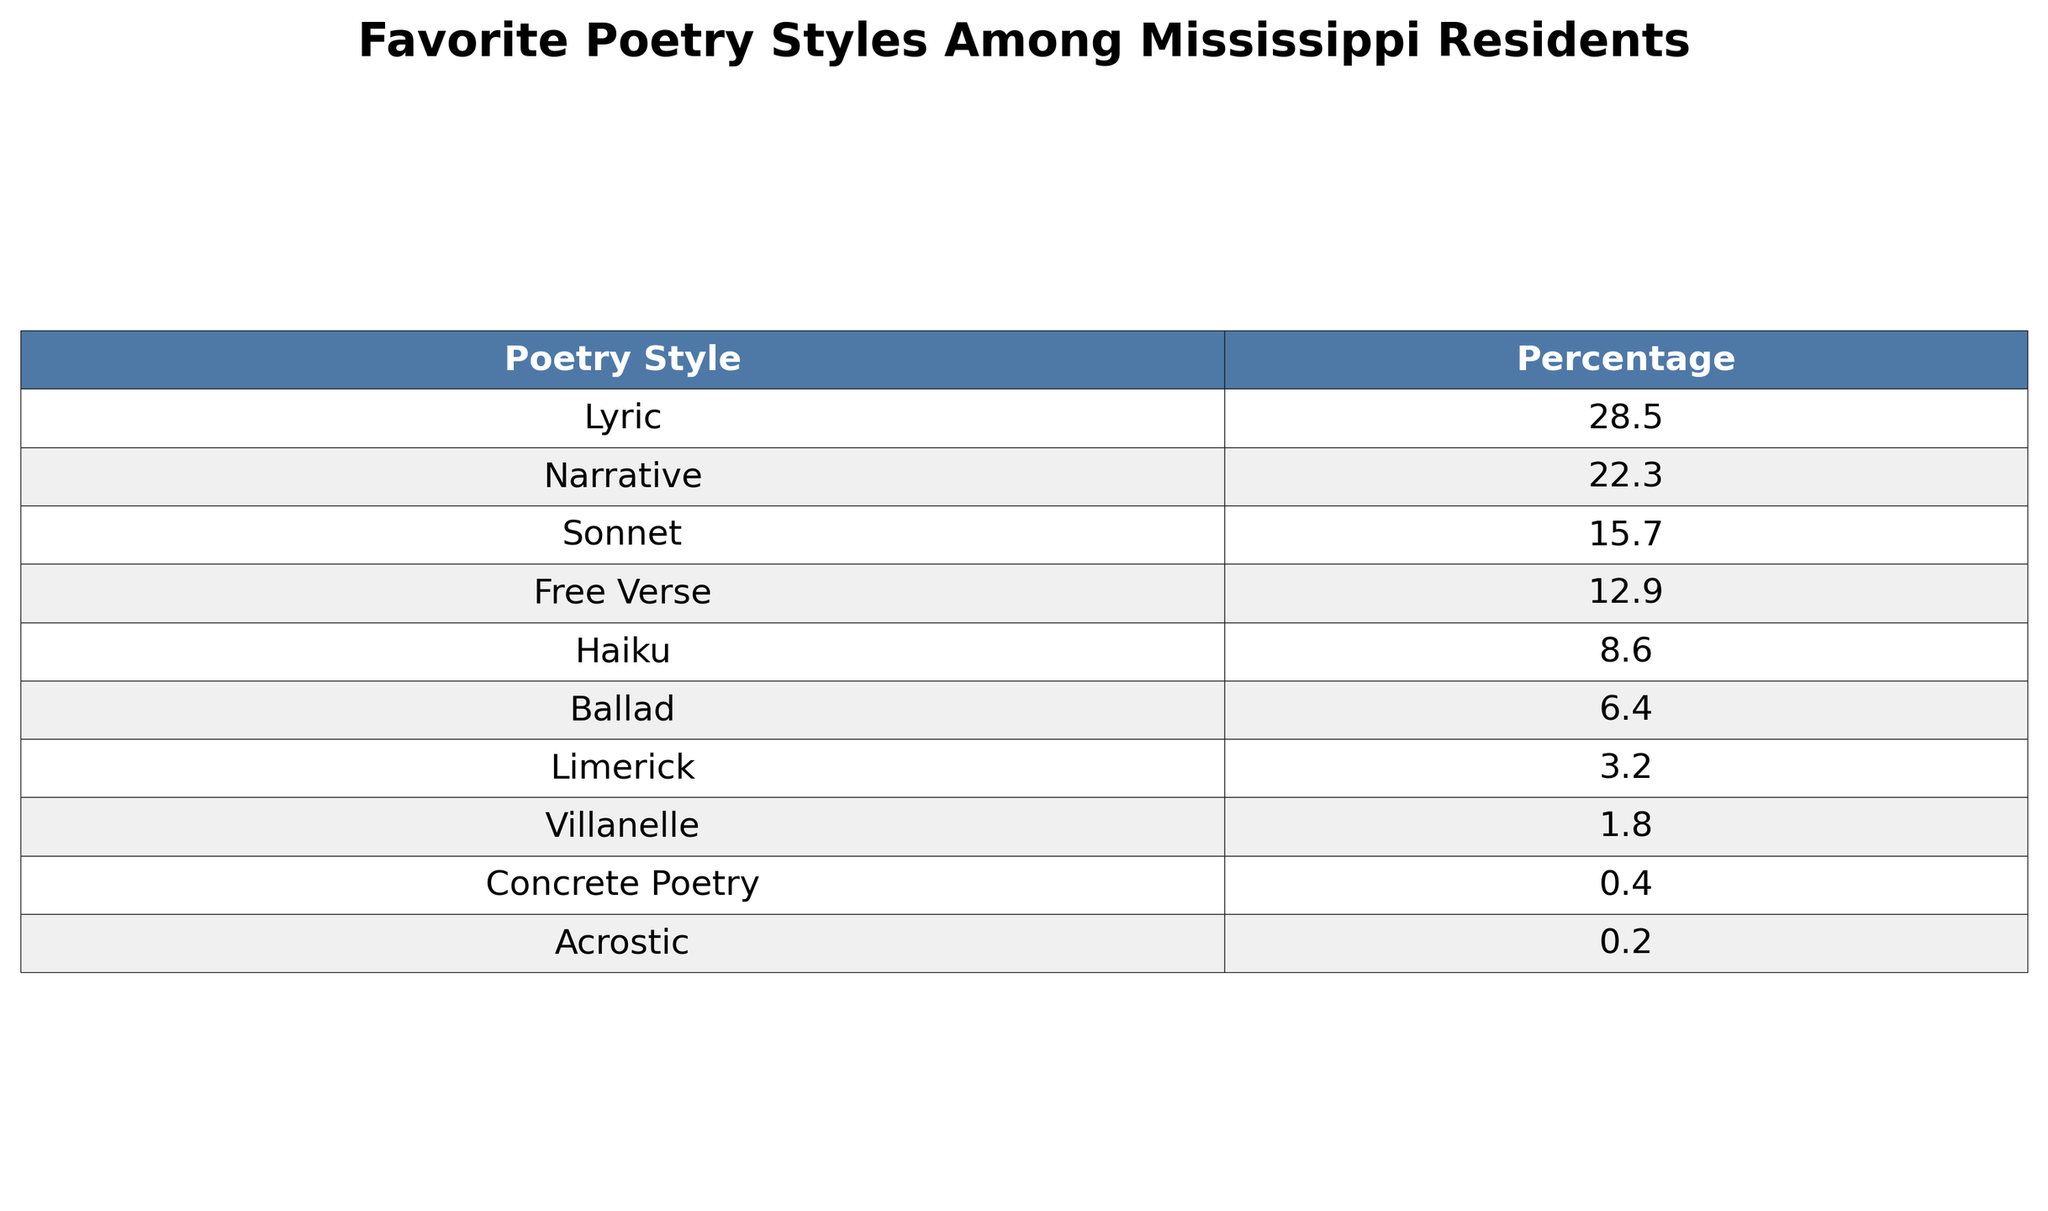What is the most popular poetry style among Mississippi residents? The table shows that the poetry style with the highest percentage is "Lyric," which has a percentage of 28.5.
Answer: Lyric How many percentage points separate the second and third ranked poetry styles? The second ranked style is "Narrative" with 22.3%, and the third ranked is "Sonnet" with 15.7%. The difference is 22.3 - 15.7 = 6.6 percentage points.
Answer: 6.6 Is "Haiku" more popular than "Ballad" among residents? The table shows that "Haiku" has a percentage of 8.6%, while "Ballad" has 6.4%. Since 8.6% is greater than 6.4%, "Haiku" is indeed more popular than "Ballad."
Answer: Yes What percentage of residents prefer Free Verse or lower-ranked styles combined? "Free Verse" has 12.9%, "Ballad" has 6.4%, "Limerick" has 3.2%, "Villanelle" has 1.8%, "Concrete Poetry" has 0.4%, and "Acrostic" has 0.2%. Adding these percentages gives 12.9 + 6.4 + 3.2 + 1.8 + 0.4 + 0.2 = 24.9%.
Answer: 24.9 What is the total percentage of residents who prefer Sonnet, Limerick, and Villanelle? The percentage for "Sonnet" is 15.7%, "Limerick" is 3.2%, and "Villanelle" is 1.8%. Adding these gives 15.7 + 3.2 + 1.8 = 20.7%.
Answer: 20.7 What percentage of residents do not prefer Concrete Poetry? "Concrete Poetry" has a percentage of 0.4%, so the percentage of residents who do not prefer it is 100% - 0.4% = 99.6%.
Answer: 99.6 Which poetry style has the lowest preference among Mississippi residents? The table indicates that "Acrostic" has the lowest preference with a percentage of 0.2%.
Answer: Acrostic How much more popular is the "Lyric" style compared to the "Villanelle"? "Lyric" has a percentage of 28.5% and "Villanelle" has 1.8%. The difference is 28.5 - 1.8 = 26.7%.
Answer: 26.7 What is the average percentage of the top three most preferred poetry styles? The top three styles are "Lyric" (28.5%), "Narrative" (22.3%), and "Sonnet" (15.7%). Adding these gives 28.5 + 22.3 + 15.7 = 66.5%. Dividing by 3 gives an average of 66.5 / 3 ≈ 22.17%.
Answer: 22.17 